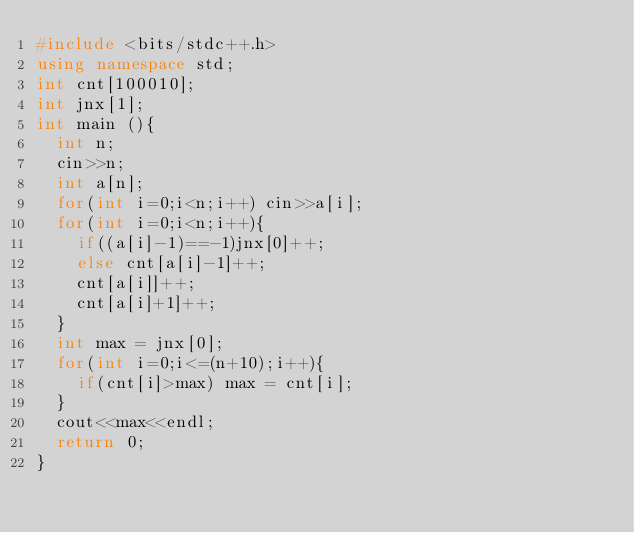<code> <loc_0><loc_0><loc_500><loc_500><_C++_>#include <bits/stdc++.h>
using namespace std;
int cnt[100010];
int jnx[1];
int main (){
	int n;
	cin>>n;
	int a[n];
	for(int i=0;i<n;i++) cin>>a[i];
	for(int i=0;i<n;i++){
		if((a[i]-1)==-1)jnx[0]++;
		else cnt[a[i]-1]++;
		cnt[a[i]]++;
		cnt[a[i]+1]++;
	}
	int max = jnx[0];
	for(int i=0;i<=(n+10);i++){
		if(cnt[i]>max) max = cnt[i];
	}
	cout<<max<<endl;
	return 0;
}</code> 